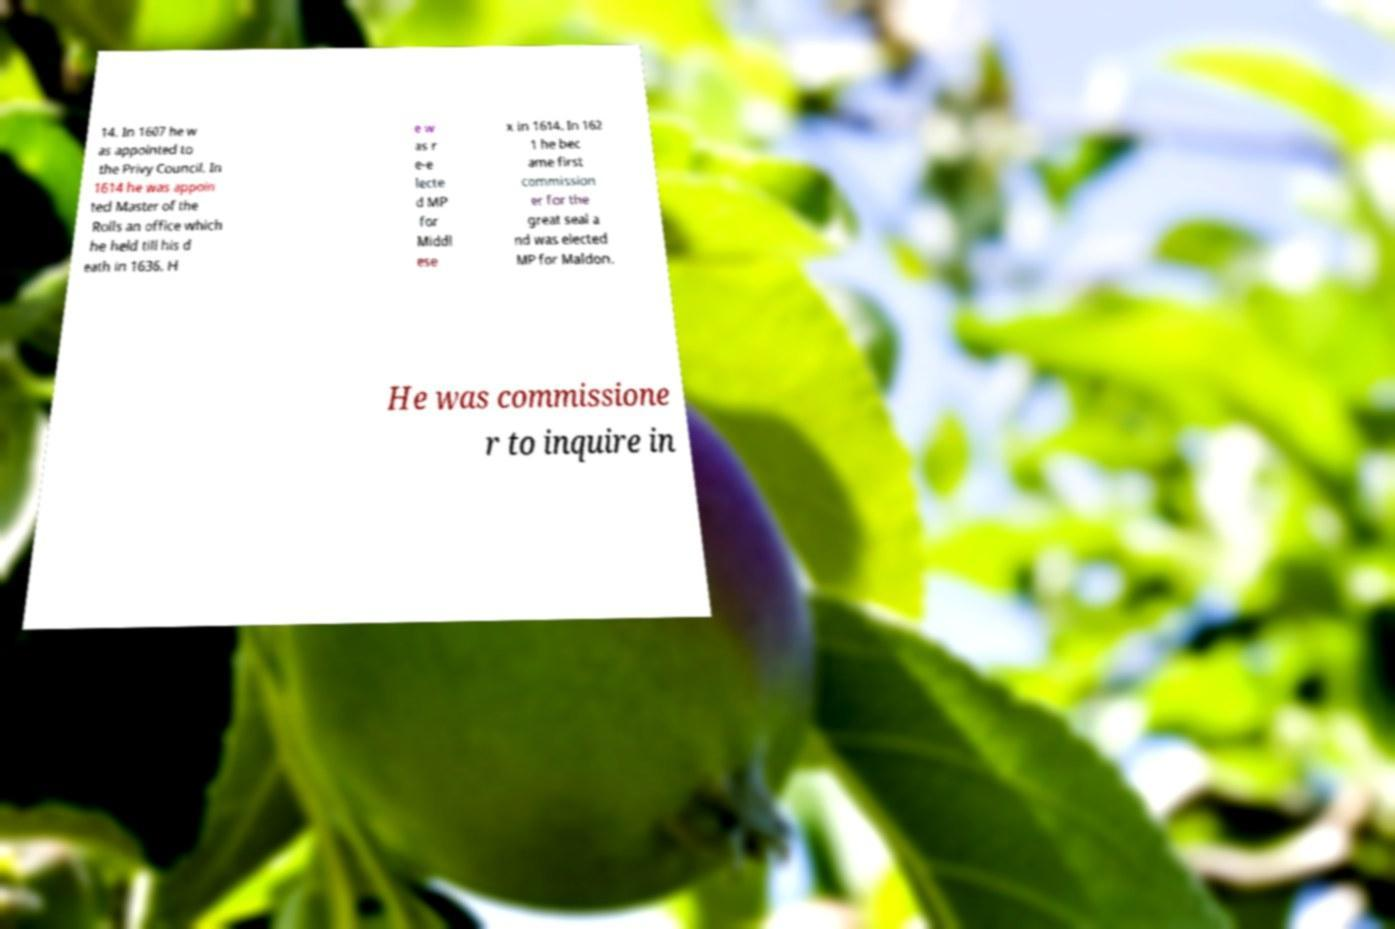Please read and relay the text visible in this image. What does it say? 14. In 1607 he w as appointed to the Privy Council. In 1614 he was appoin ted Master of the Rolls an office which he held till his d eath in 1636. H e w as r e-e lecte d MP for Middl ese x in 1614. In 162 1 he bec ame first commission er for the great seal a nd was elected MP for Maldon. He was commissione r to inquire in 